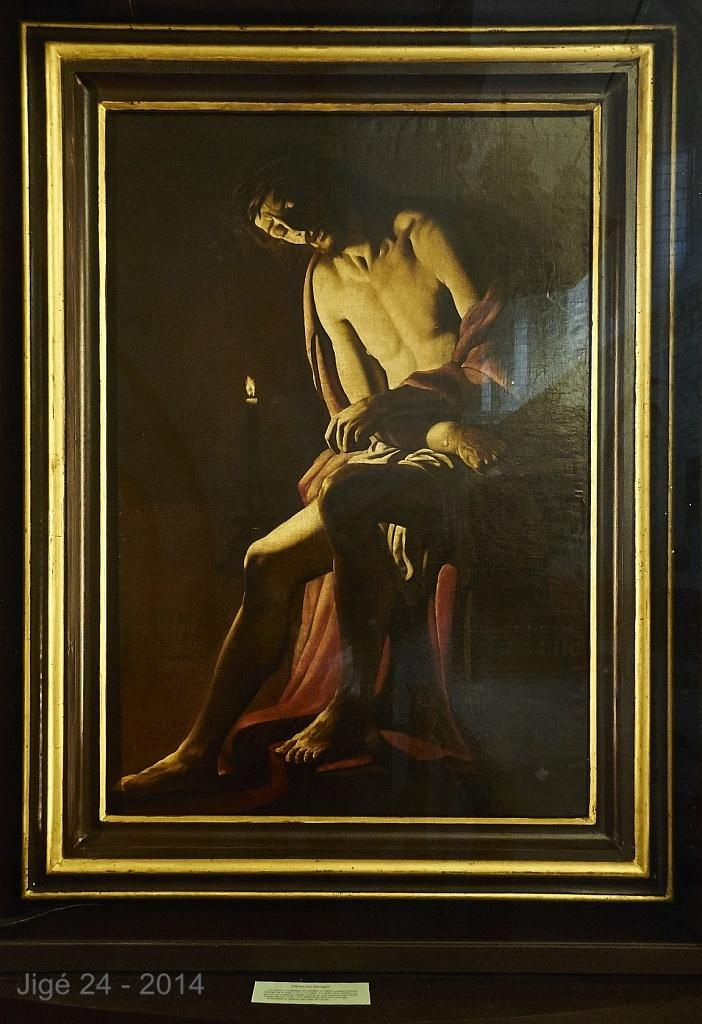Provide a one-sentence caption for the provided image. A framed portrait of a man created in the year 2014. 